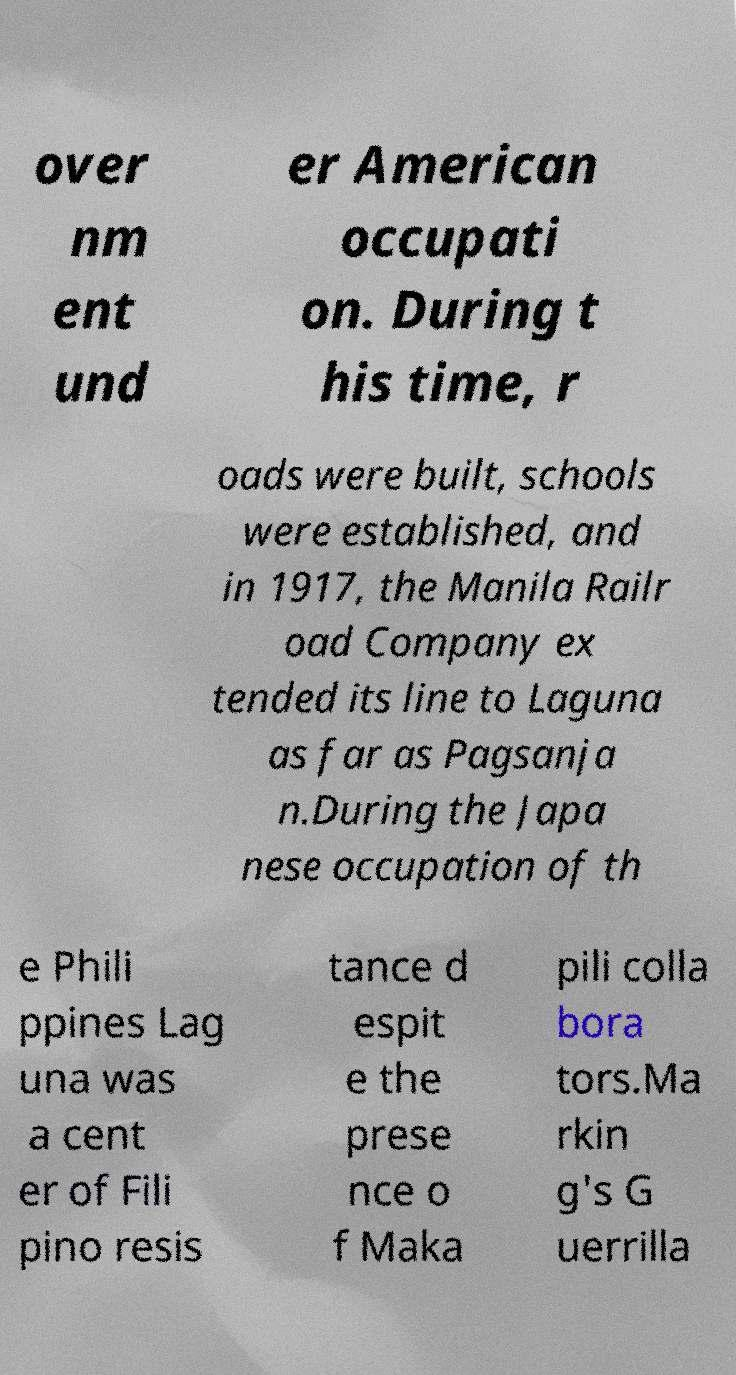Please read and relay the text visible in this image. What does it say? over nm ent und er American occupati on. During t his time, r oads were built, schools were established, and in 1917, the Manila Railr oad Company ex tended its line to Laguna as far as Pagsanja n.During the Japa nese occupation of th e Phili ppines Lag una was a cent er of Fili pino resis tance d espit e the prese nce o f Maka pili colla bora tors.Ma rkin g's G uerrilla 